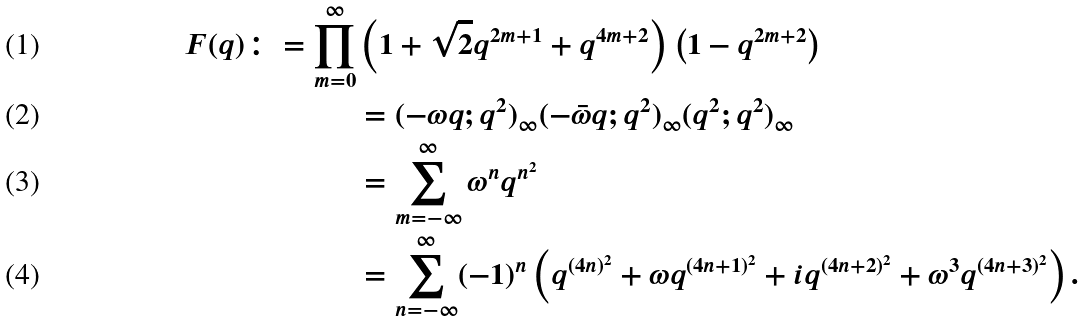Convert formula to latex. <formula><loc_0><loc_0><loc_500><loc_500>F ( q ) \colon = \prod _ { m = 0 } ^ { \infty } & \left ( 1 + \sqrt { 2 } q ^ { 2 m + 1 } + q ^ { 4 m + 2 } \right ) \left ( 1 - q ^ { 2 m + 2 } \right ) \\ & = ( - \omega q ; q ^ { 2 } ) _ { \infty } ( - \bar { \omega } q ; q ^ { 2 } ) _ { \infty } ( q ^ { 2 } ; q ^ { 2 } ) _ { \infty } \\ & = \sum _ { m = - \infty } ^ { \infty } \omega ^ { n } q ^ { n ^ { 2 } } \\ & = \sum _ { n = - \infty } ^ { \infty } ( - 1 ) ^ { n } \left ( q ^ { ( 4 n ) ^ { 2 } } + \omega q ^ { ( 4 n + 1 ) ^ { 2 } } + i q ^ { ( 4 n + 2 ) ^ { 2 } } + \omega ^ { 3 } q ^ { ( 4 n + 3 ) ^ { 2 } } \right ) .</formula> 